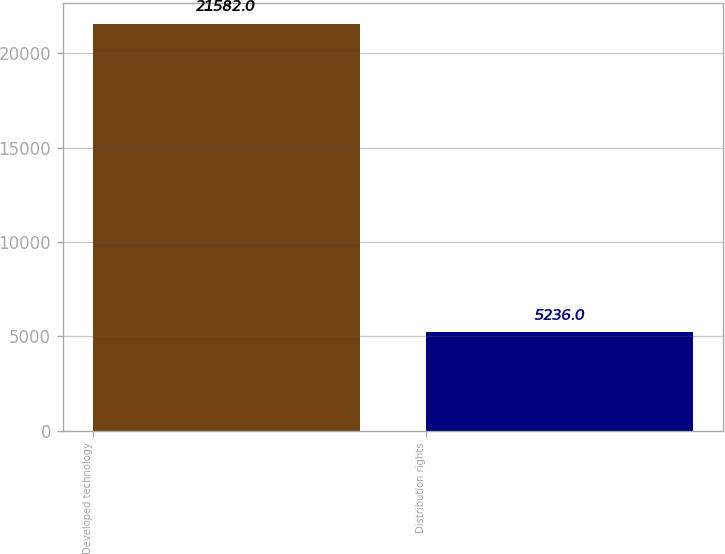Convert chart. <chart><loc_0><loc_0><loc_500><loc_500><bar_chart><fcel>Developed technology<fcel>Distribution rights<nl><fcel>21582<fcel>5236<nl></chart> 